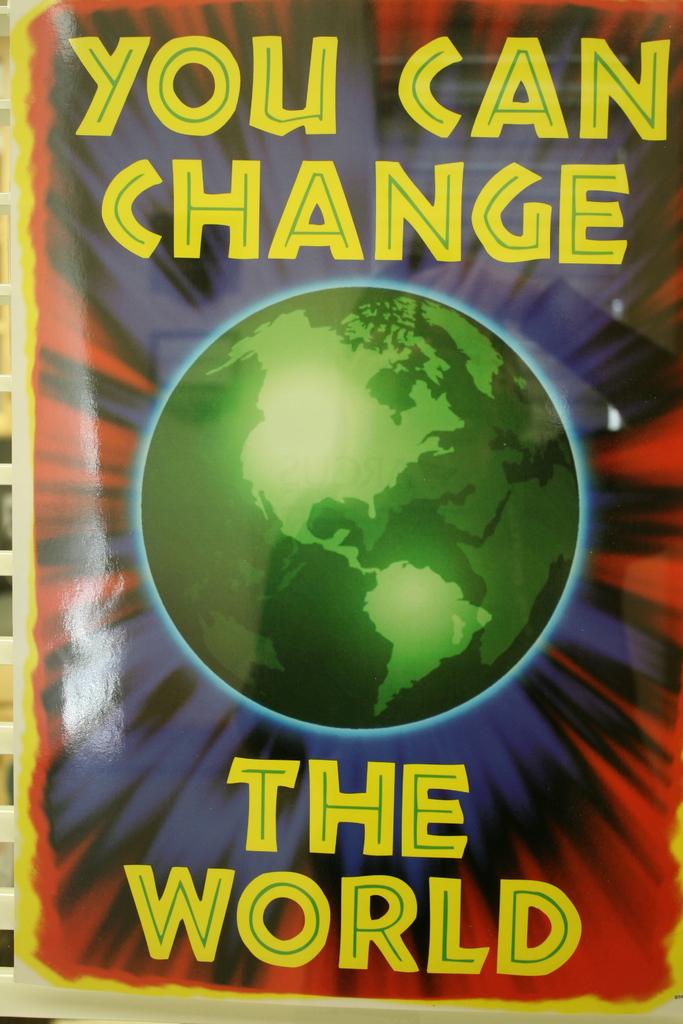What is this books title?
Offer a very short reply. You can change the world. What color is the title of this book?
Offer a very short reply. Yellow. 